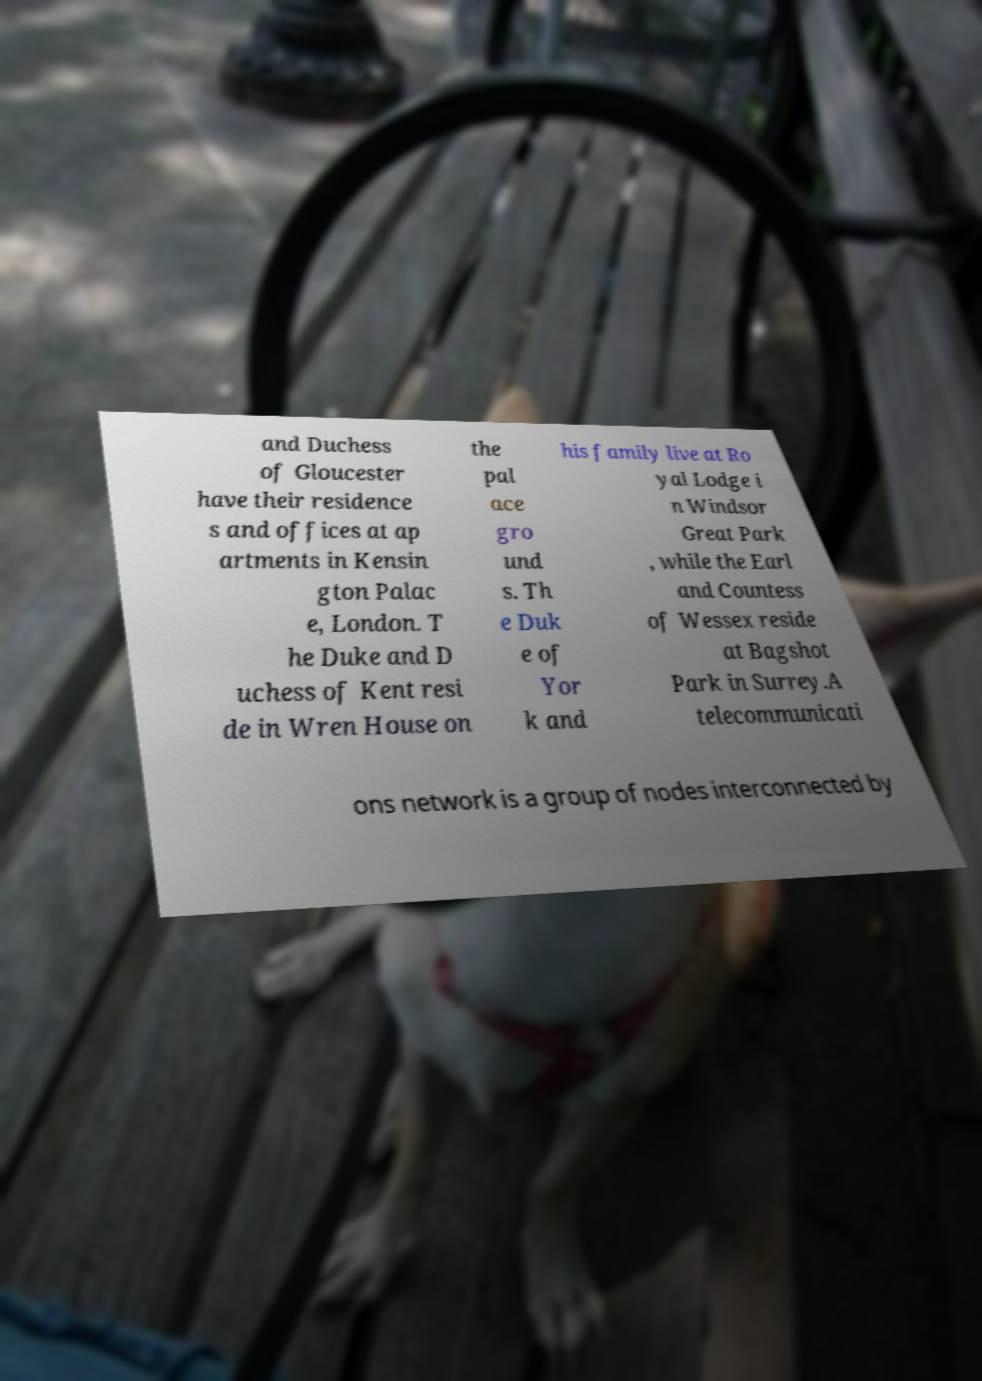Could you assist in decoding the text presented in this image and type it out clearly? and Duchess of Gloucester have their residence s and offices at ap artments in Kensin gton Palac e, London. T he Duke and D uchess of Kent resi de in Wren House on the pal ace gro und s. Th e Duk e of Yor k and his family live at Ro yal Lodge i n Windsor Great Park , while the Earl and Countess of Wessex reside at Bagshot Park in Surrey.A telecommunicati ons network is a group of nodes interconnected by 